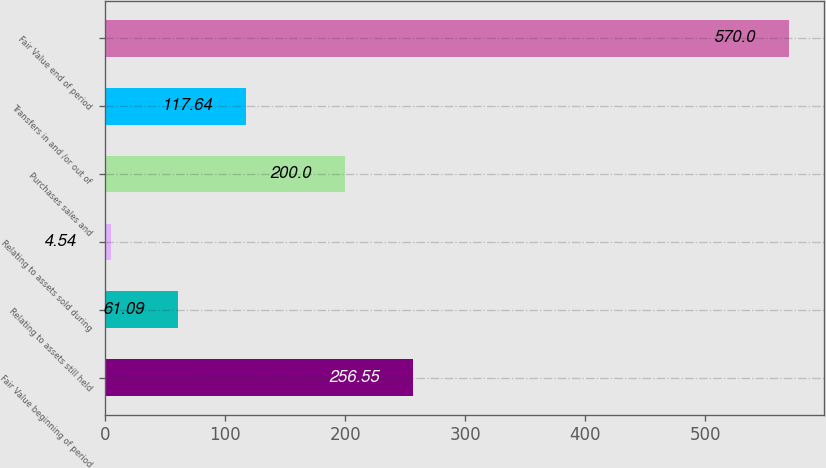<chart> <loc_0><loc_0><loc_500><loc_500><bar_chart><fcel>Fair Value beginning of period<fcel>Relating to assets still held<fcel>Relating to assets sold during<fcel>Purchases sales and<fcel>Transfers in and /or out of<fcel>Fair Value end of period<nl><fcel>256.55<fcel>61.09<fcel>4.54<fcel>200<fcel>117.64<fcel>570<nl></chart> 